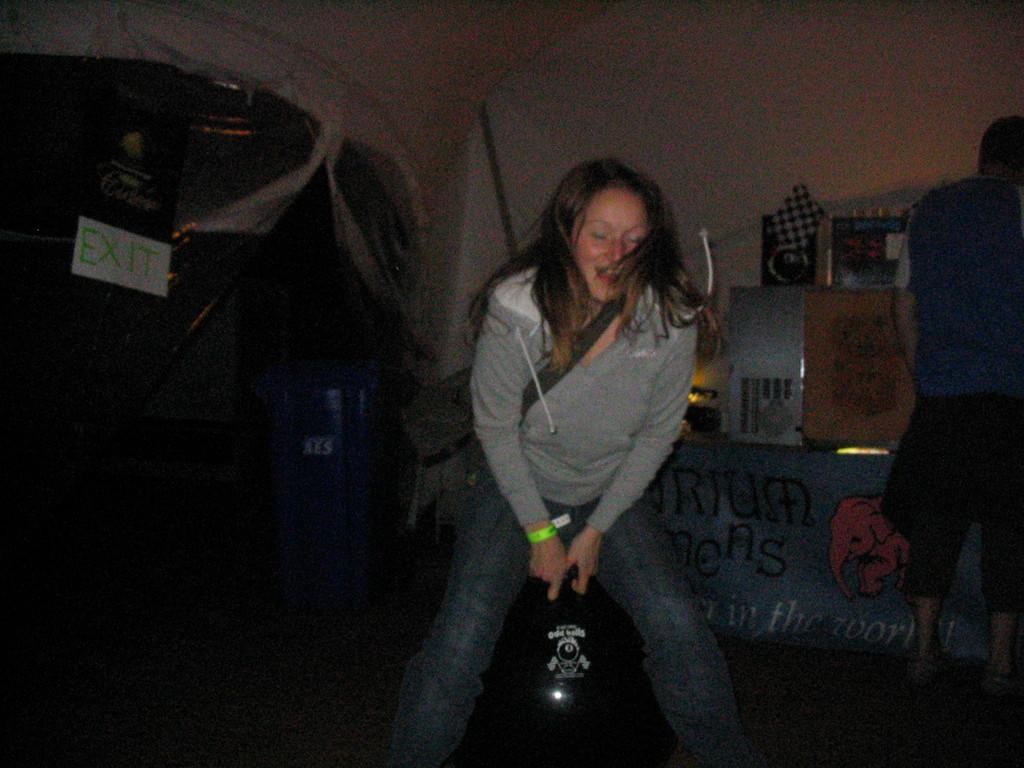Can you describe this image briefly? In this picture I can see a woman in front who is holding a thing and behind her I can see a man. In the background I can see number of things and I see board on which there are words written and I can see the wall. I see that it is dark on the bottom left of this picture. 